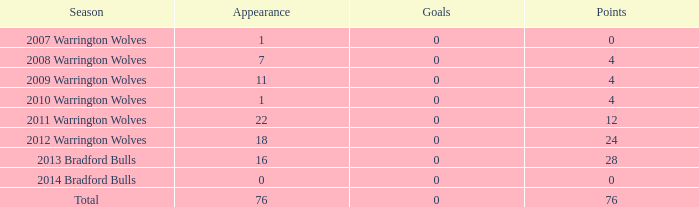In what number of cases are "tries" 0 and "appearance" below 0? 0.0. 